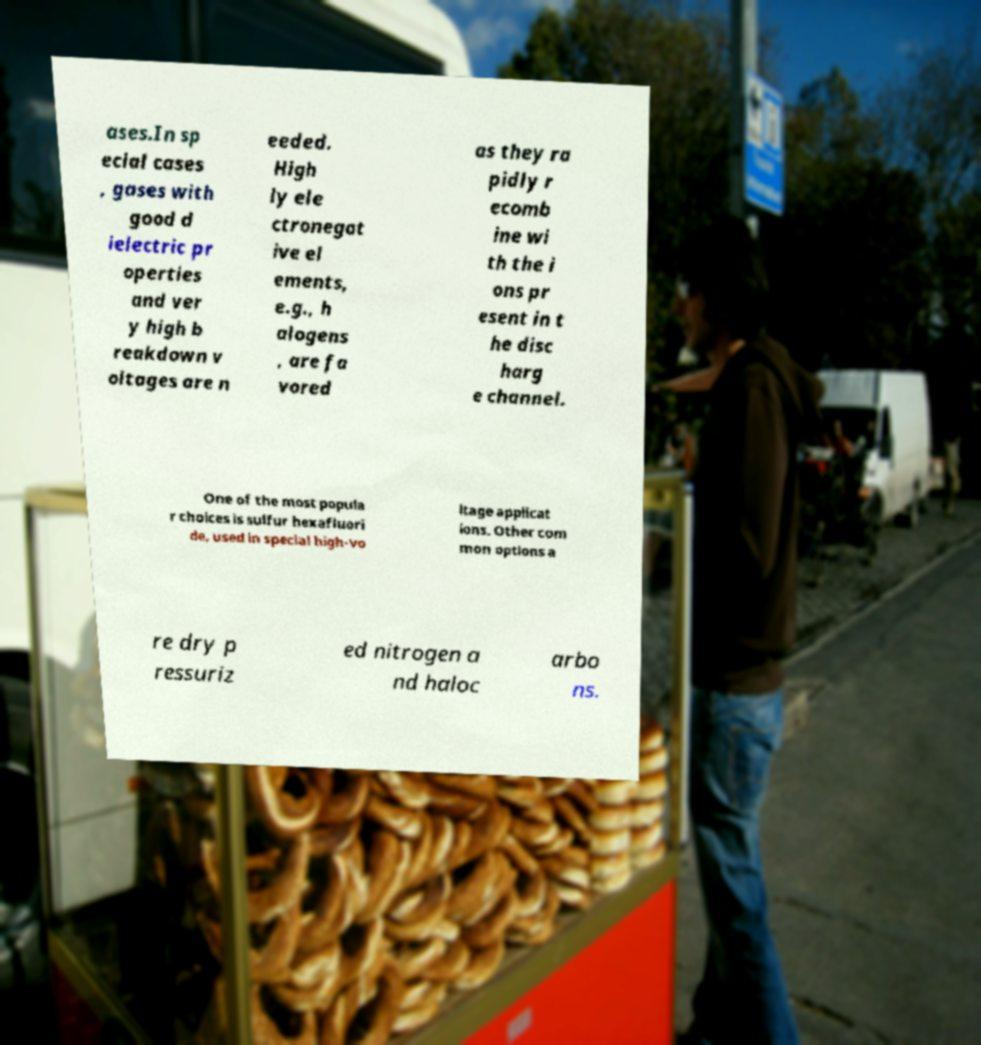Could you extract and type out the text from this image? ases.In sp ecial cases , gases with good d ielectric pr operties and ver y high b reakdown v oltages are n eeded. High ly ele ctronegat ive el ements, e.g., h alogens , are fa vored as they ra pidly r ecomb ine wi th the i ons pr esent in t he disc harg e channel. One of the most popula r choices is sulfur hexafluori de, used in special high-vo ltage applicat ions. Other com mon options a re dry p ressuriz ed nitrogen a nd haloc arbo ns. 